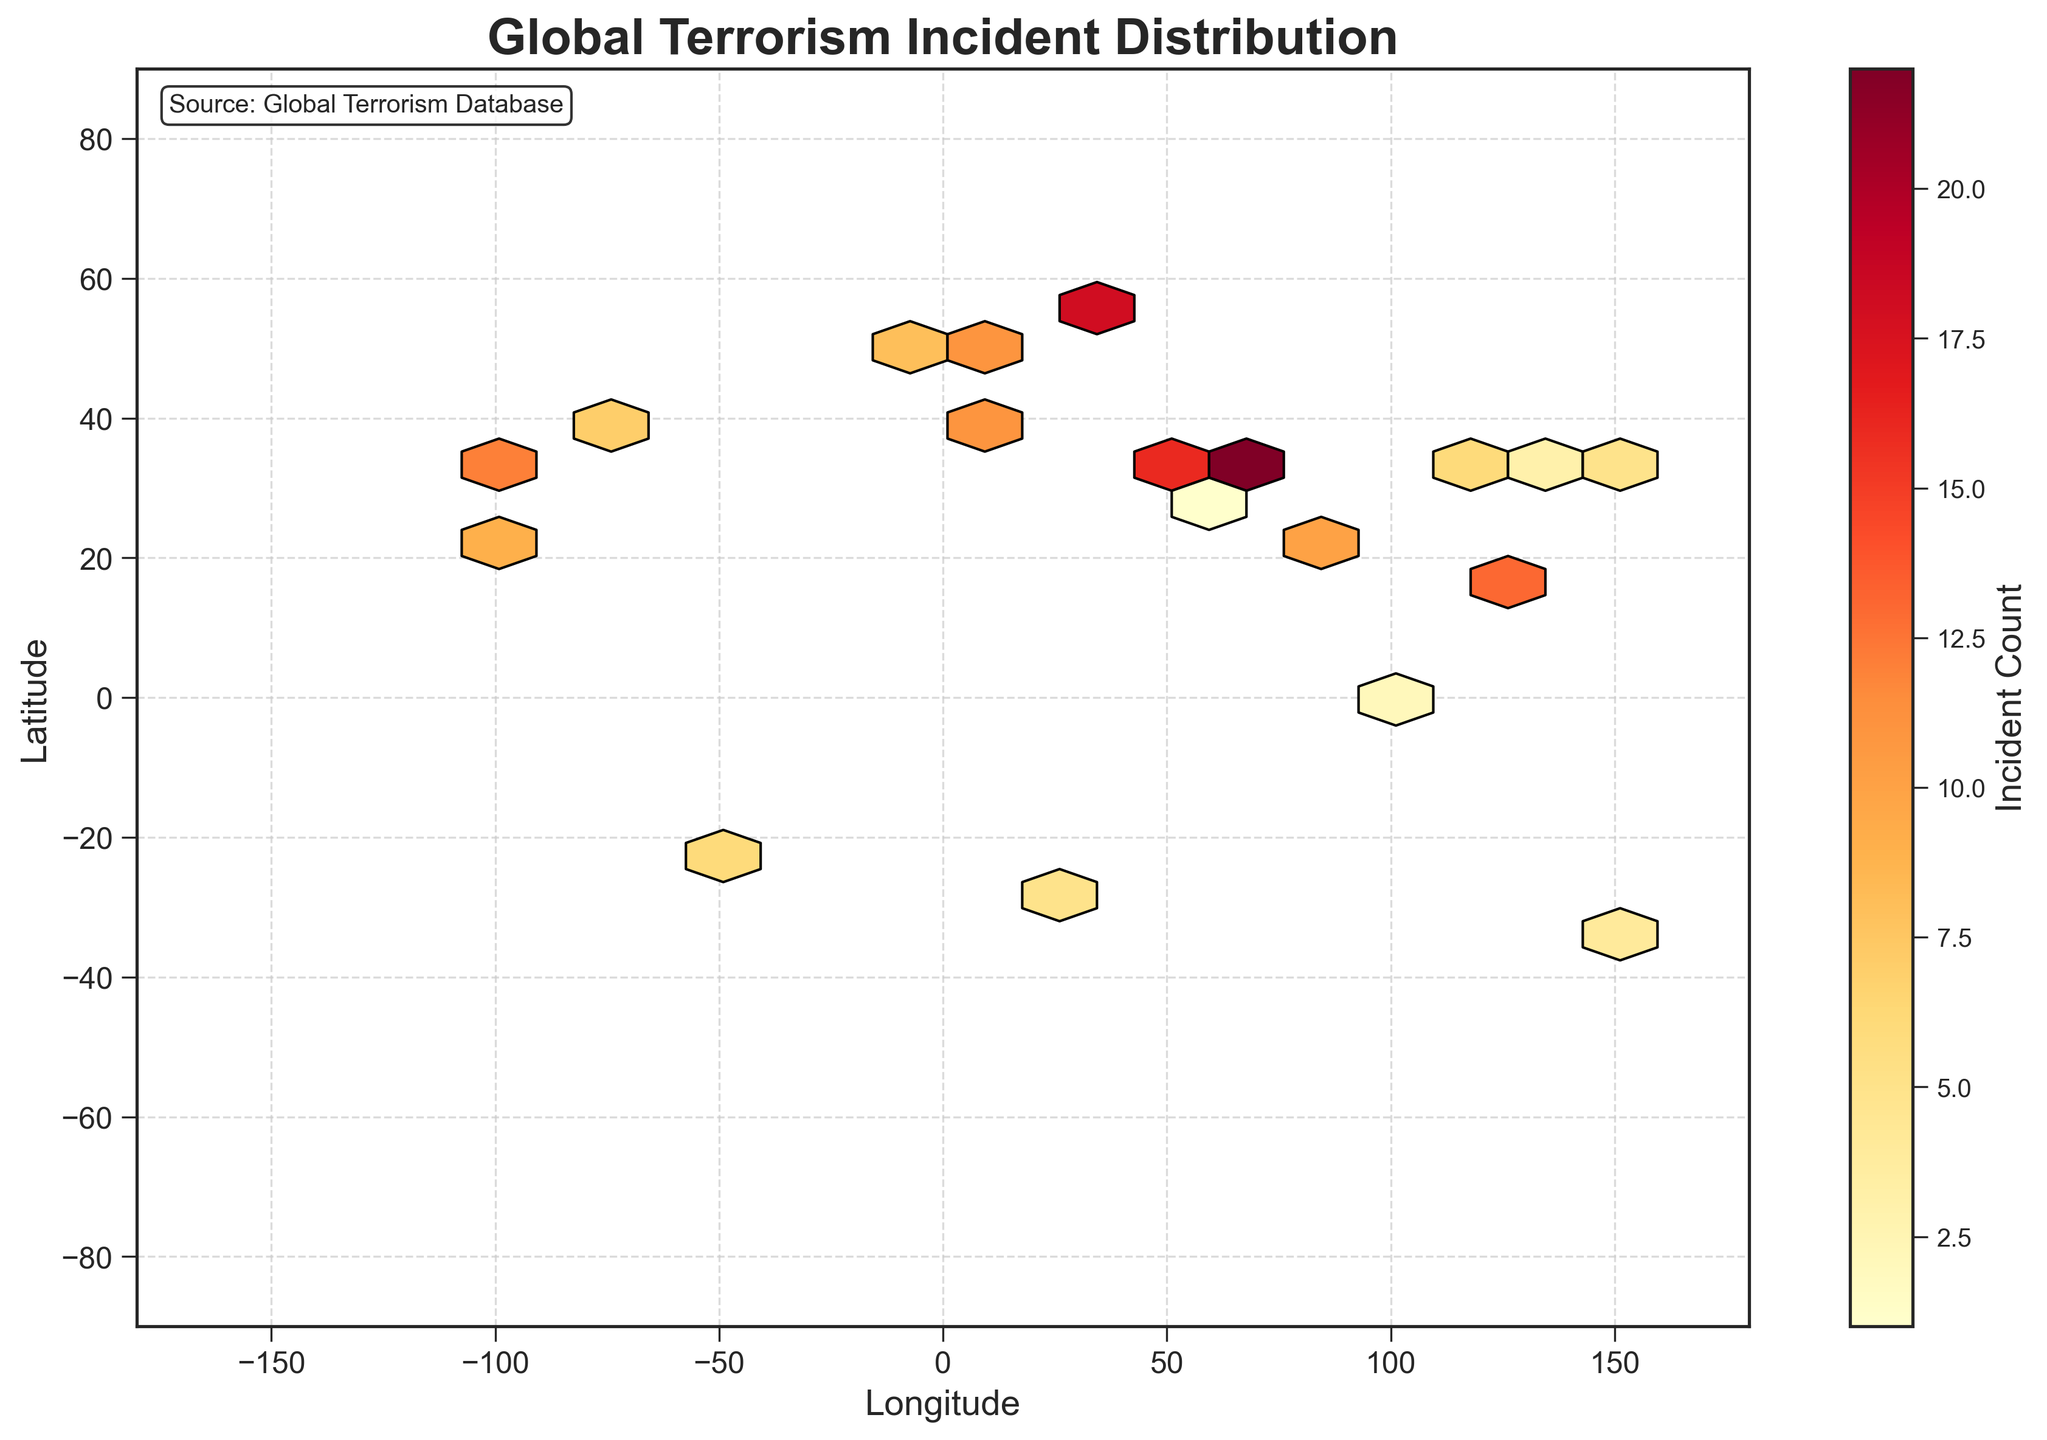What is the title of the figure? The title is located at the top of the figure and clearly states the main subject of the plot.
Answer: Global Terrorism Incident Distribution What do the colors on the hexagonal bins represent? The color scale on the hexagonal bins is explained by the color bar to the right of the plot, indicating the density of terrorist incident counts.
Answer: Incident Count What is the range of longitude values displayed in the figure? The longitude values can be found on the x-axis, spanning from -180 to 180 degrees.
Answer: -180 to 180 What information is provided by the color bar? The color bar displays the range of incident counts shaded by different colors, indicating the density of incidents over the geographic bins.
Answer: Range of incident counts Which geographic region has the highest density of terrorist incidents? By identifying the darkest and most saturated hexagonal bin on the plot, we can determine that the region around Moscow (latitude 55.7558, longitude 37.6173) has the highest density.
Answer: Moscow region How many major regions exhibit a high concentration of terrorist incidents? By examining areas with darker color shading, we see multiple high-concentration regions including Moscow, Tehran, Islamabad, and Baghdad.
Answer: 4 How does the incident count in New York City compare to that in Paris? The color shading in New York City is less saturated than in Paris, indicating a lower incident count. Paris has a higher count.
Answer: Paris has more Among the cities shown, which one has the least number of terrorist incidents? The lightest colored hexagonal bin helps identify that Dubai (latitude 25.2048, longitude 55.2708) with the fewest incidents.
Answer: Dubai What is the maximum value displayed on the color bar? The top value on the color bar provides the maximum incident count represented on the plot.
Answer: 22 Which city on the plot is closest to the longitude of 80 degrees and what is its incident count? By locating the bin close to longitude 80 on the x-axis and checking for the latitude precisely, Dhaka (latitude 23.8103, longitude 90.4125) with an incident count of 10 stands out.
Answer: Dhaka, 10 